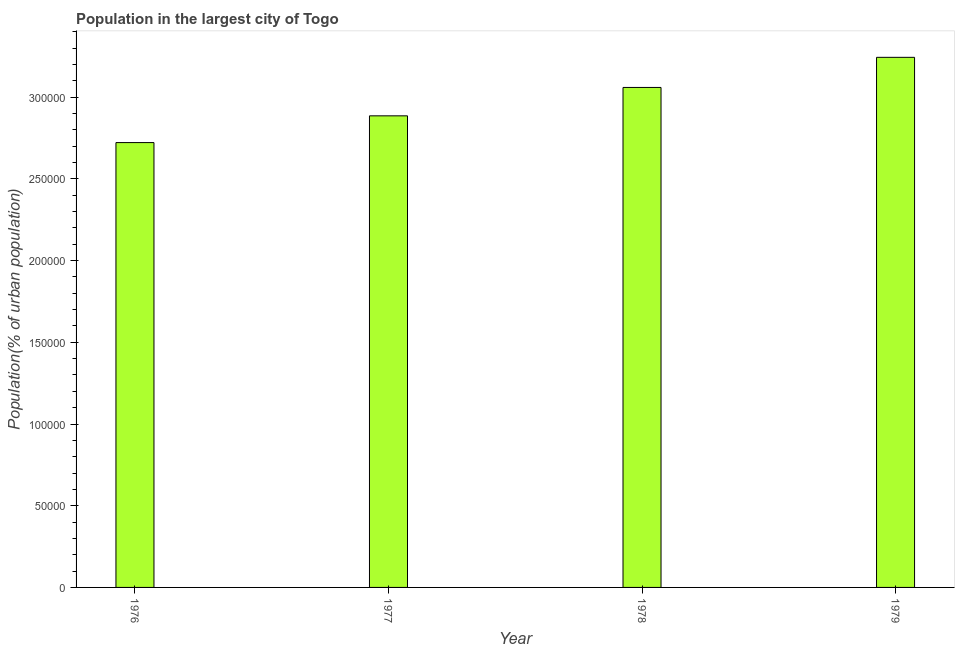What is the title of the graph?
Provide a succinct answer. Population in the largest city of Togo. What is the label or title of the Y-axis?
Keep it short and to the point. Population(% of urban population). What is the population in largest city in 1979?
Make the answer very short. 3.24e+05. Across all years, what is the maximum population in largest city?
Offer a very short reply. 3.24e+05. Across all years, what is the minimum population in largest city?
Offer a very short reply. 2.72e+05. In which year was the population in largest city maximum?
Your answer should be very brief. 1979. In which year was the population in largest city minimum?
Ensure brevity in your answer.  1976. What is the sum of the population in largest city?
Your response must be concise. 1.19e+06. What is the difference between the population in largest city in 1977 and 1978?
Offer a very short reply. -1.74e+04. What is the average population in largest city per year?
Keep it short and to the point. 2.98e+05. What is the median population in largest city?
Ensure brevity in your answer.  2.97e+05. In how many years, is the population in largest city greater than 60000 %?
Offer a very short reply. 4. What is the ratio of the population in largest city in 1976 to that in 1978?
Your response must be concise. 0.89. Is the population in largest city in 1977 less than that in 1978?
Your answer should be very brief. Yes. What is the difference between the highest and the second highest population in largest city?
Give a very brief answer. 1.84e+04. What is the difference between the highest and the lowest population in largest city?
Your response must be concise. 5.22e+04. How many bars are there?
Provide a short and direct response. 4. What is the difference between two consecutive major ticks on the Y-axis?
Provide a succinct answer. 5.00e+04. Are the values on the major ticks of Y-axis written in scientific E-notation?
Make the answer very short. No. What is the Population(% of urban population) of 1976?
Give a very brief answer. 2.72e+05. What is the Population(% of urban population) of 1977?
Provide a short and direct response. 2.89e+05. What is the Population(% of urban population) of 1978?
Make the answer very short. 3.06e+05. What is the Population(% of urban population) of 1979?
Ensure brevity in your answer.  3.24e+05. What is the difference between the Population(% of urban population) in 1976 and 1977?
Give a very brief answer. -1.64e+04. What is the difference between the Population(% of urban population) in 1976 and 1978?
Provide a succinct answer. -3.38e+04. What is the difference between the Population(% of urban population) in 1976 and 1979?
Give a very brief answer. -5.22e+04. What is the difference between the Population(% of urban population) in 1977 and 1978?
Your answer should be very brief. -1.74e+04. What is the difference between the Population(% of urban population) in 1977 and 1979?
Offer a very short reply. -3.58e+04. What is the difference between the Population(% of urban population) in 1978 and 1979?
Ensure brevity in your answer.  -1.84e+04. What is the ratio of the Population(% of urban population) in 1976 to that in 1977?
Offer a terse response. 0.94. What is the ratio of the Population(% of urban population) in 1976 to that in 1978?
Ensure brevity in your answer.  0.89. What is the ratio of the Population(% of urban population) in 1976 to that in 1979?
Your response must be concise. 0.84. What is the ratio of the Population(% of urban population) in 1977 to that in 1978?
Make the answer very short. 0.94. What is the ratio of the Population(% of urban population) in 1977 to that in 1979?
Provide a succinct answer. 0.89. What is the ratio of the Population(% of urban population) in 1978 to that in 1979?
Give a very brief answer. 0.94. 